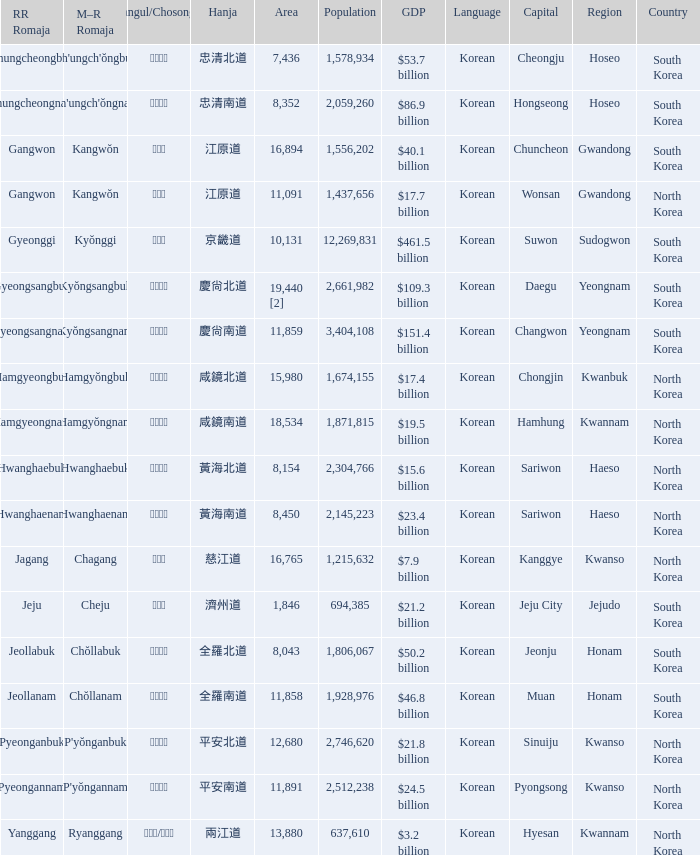What is the RR Romaja for the province that has Hangul of 강원도 and capital of Wonsan? Gangwon. 